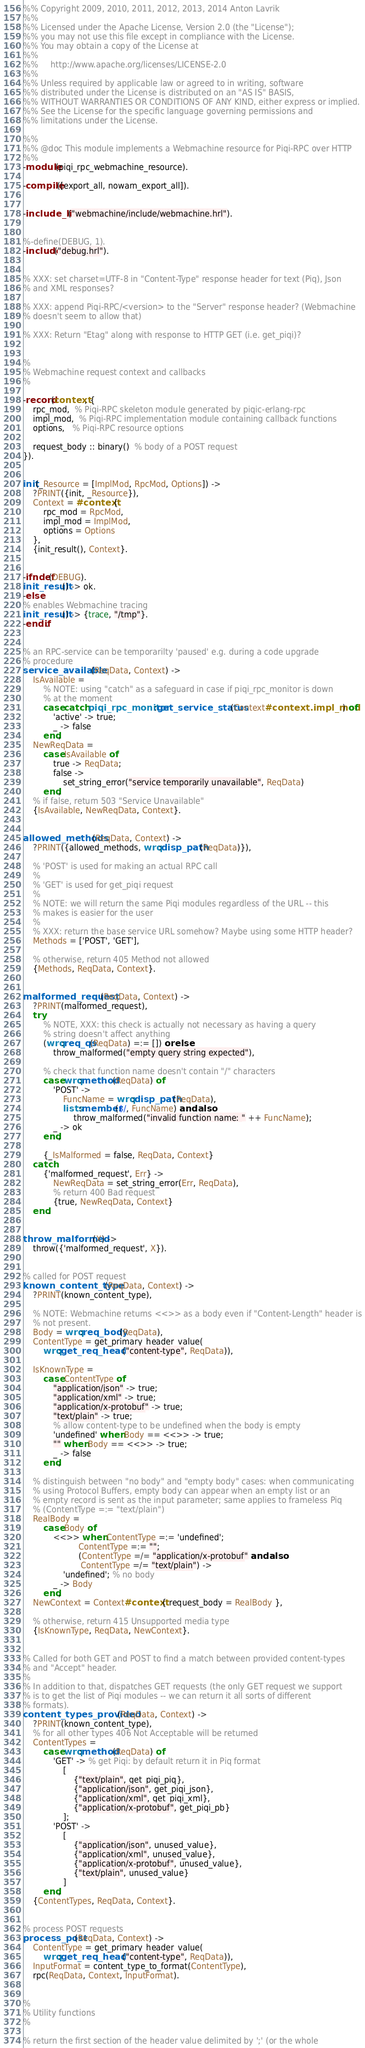Convert code to text. <code><loc_0><loc_0><loc_500><loc_500><_Erlang_>%% Copyright 2009, 2010, 2011, 2012, 2013, 2014 Anton Lavrik
%%
%% Licensed under the Apache License, Version 2.0 (the "License");
%% you may not use this file except in compliance with the License.
%% You may obtain a copy of the License at
%%
%%     http://www.apache.org/licenses/LICENSE-2.0
%%
%% Unless required by applicable law or agreed to in writing, software
%% distributed under the License is distributed on an "AS IS" BASIS,
%% WITHOUT WARRANTIES OR CONDITIONS OF ANY KIND, either express or implied.
%% See the License for the specific language governing permissions and
%% limitations under the License.

%%
%% @doc This module implements a Webmachine resource for Piqi-RPC over HTTP
%%
-module(piqi_rpc_webmachine_resource).

-compile([export_all, nowarn_export_all]).


-include_lib("webmachine/include/webmachine.hrl").


%-define(DEBUG, 1).
-include("debug.hrl").


% XXX: set charset=UTF-8 in "Content-Type" response header for text (Piq), Json
% and XML responses?

% XXX: append Piqi-RPC/<version> to the "Server" response header? (Webmachine
% doesn't seem to allow that)

% XXX: Return "Etag" along with response to HTTP GET (i.e. get_piqi)?


%
% Webmachine request context and callbacks
%

-record(context, {
    rpc_mod,  % Piqi-RPC skeleton module generated by piqic-erlang-rpc
    impl_mod,  % Piqi-RPC implementation module containing callback functions
    options,   % Piqi-RPC resource options

    request_body :: binary()  % body of a POST request
}).


init(_Resource = [ImplMod, RpcMod, Options]) ->
    ?PRINT({init, _Resource}),
    Context = #context{
        rpc_mod = RpcMod,
        impl_mod = ImplMod,
        options = Options
    },
    {init_result(), Context}.


-ifndef(DEBUG).
init_result() -> ok.
-else.
% enables Webmachine tracing
init_result() -> {trace, "/tmp"}.
-endif.


% an RPC-service can be temporarilty 'paused' e.g. during a code upgrade
% procedure
service_available(ReqData, Context) ->
    IsAvailable =
        % NOTE: using "catch" as a safeguard in case if piqi_rpc_monitor is down
        % at the moment
        case catch piqi_rpc_monitor:get_service_status(Context#context.impl_mod) of
            'active' -> true;
            _ -> false
        end,
    NewReqData =
        case IsAvailable of
            true -> ReqData;
            false ->
                set_string_error("service temporarily unavailable", ReqData)
        end,
    % if false, return 503 "Service Unavailable"
    {IsAvailable, NewReqData, Context}.


allowed_methods(ReqData, Context) ->
    ?PRINT({allowed_methods, wrq:disp_path(ReqData)}),

    % 'POST' is used for making an actual RPC call
    %
    % 'GET' is used for get_piqi request
    %
    % NOTE: we will return the same Piqi modules regardless of the URL -- this
    % makes is easier for the user
    %
    % XXX: return the base service URL somehow? Maybe using some HTTP header?
    Methods = ['POST', 'GET'],

    % otherwise, return 405 Method not allowed
    {Methods, ReqData, Context}.


malformed_request(ReqData, Context) ->
    ?PRINT(malformed_request),
    try
        % NOTE, XXX: this check is actually not necessary as having a query
        % string doesn't affect anything
        (wrq:req_qs(ReqData) =:= []) orelse
            throw_malformed("empty query string expected"),

        % check that function name doesn't contain "/" characters
        case wrq:method(ReqData) of
            'POST' ->
                FuncName = wrq:disp_path(ReqData),
                lists:member($/, FuncName) andalso
                    throw_malformed("invalid function name: " ++ FuncName);
            _ -> ok
        end,

        {_IsMalformed = false, ReqData, Context}
    catch
        {'malformed_request', Err} ->
            NewReqData = set_string_error(Err, ReqData),
            % return 400 Bad request
            {true, NewReqData, Context}
    end.


throw_malformed(X) ->
    throw({'malformed_request', X}).


% called for POST request
known_content_type(ReqData, Context) ->
    ?PRINT(known_content_type),

    % NOTE: Webmachine returns <<>> as a body even if "Content-Length" header is
    % not present.
    Body = wrq:req_body(ReqData),
    ContentType = get_primary_header_value(
        wrq:get_req_header("content-type", ReqData)),

    IsKnownType =
        case ContentType of
            "application/json" -> true;
            "application/xml" -> true;
            "application/x-protobuf" -> true;
            "text/plain" -> true;
            % allow content-type to be undefined when the body is empty
            'undefined' when Body == <<>> -> true;
            "" when Body == <<>> -> true;
            _ -> false
        end,

    % distinguish between "no body" and "empty body" cases: when communicating
    % using Protocol Buffers, empty body can appear when an empty list or an
    % empty record is sent as the input parameter; same applies to frameless Piq
    % (ContentType =:= "text/plain")
    RealBody =
        case Body of
            <<>> when ContentType =:= 'undefined';
                      ContentType =:= "";
                      (ContentType =/= "application/x-protobuf" andalso
                       ContentType =/= "text/plain") ->
                'undefined'; % no body
            _ -> Body
        end,
    NewContext = Context#context{ request_body = RealBody },

    % otherwise, return 415 Unsupported media type
    {IsKnownType, ReqData, NewContext}.


% Called for both GET and POST to find a match between provided content-types
% and "Accept" header.
%
% In addition to that, dispatches GET requests (the only GET request we support
% is to get the list of Piqi modules -- we can return it all sorts of different
% formats).
content_types_provided(ReqData, Context) ->
    ?PRINT(known_content_type),
    % for all other types 406 Not Acceptable will be returned
    ContentTypes =
        case wrq:method(ReqData) of
            'GET' -> % get Piqi: by default return it in Piq format
                [
                    {"text/plain", get_piqi_piq},
                    {"application/json", get_piqi_json},
                    {"application/xml", get_piqi_xml},
                    {"application/x-protobuf", get_piqi_pb}
                ];
            'POST' ->
                [
                    {"application/json", unused_value},
                    {"application/xml", unused_value},
                    {"application/x-protobuf", unused_value},
                    {"text/plain", unused_value}
                ]
        end,
    {ContentTypes, ReqData, Context}.


% process POST requests
process_post(ReqData, Context) ->
    ContentType = get_primary_header_value(
        wrq:get_req_header("content-type", ReqData)),
    InputFormat = content_type_to_format(ContentType),
    rpc(ReqData, Context, InputFormat).


%
% Utility functions
%

% return the first section of the header value delimited by ';' (or the whole</code> 